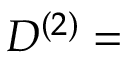<formula> <loc_0><loc_0><loc_500><loc_500>D ^ { ( 2 ) } =</formula> 